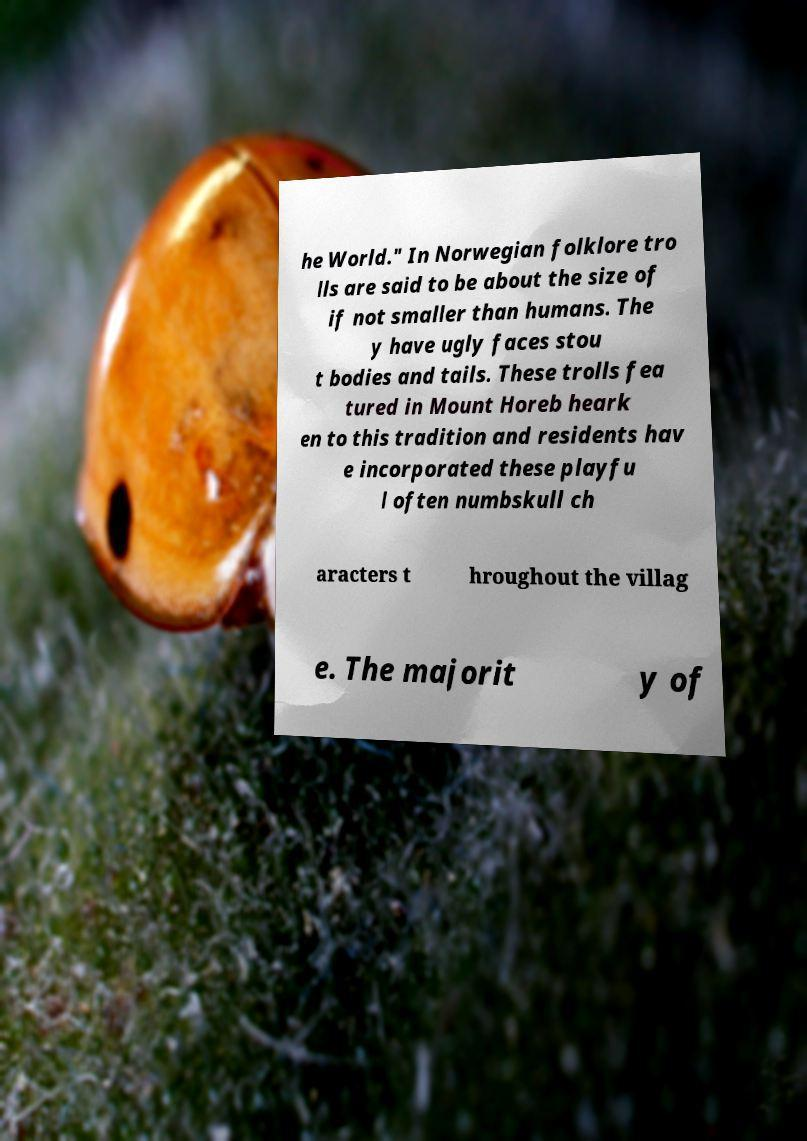What messages or text are displayed in this image? I need them in a readable, typed format. he World." In Norwegian folklore tro lls are said to be about the size of if not smaller than humans. The y have ugly faces stou t bodies and tails. These trolls fea tured in Mount Horeb heark en to this tradition and residents hav e incorporated these playfu l often numbskull ch aracters t hroughout the villag e. The majorit y of 